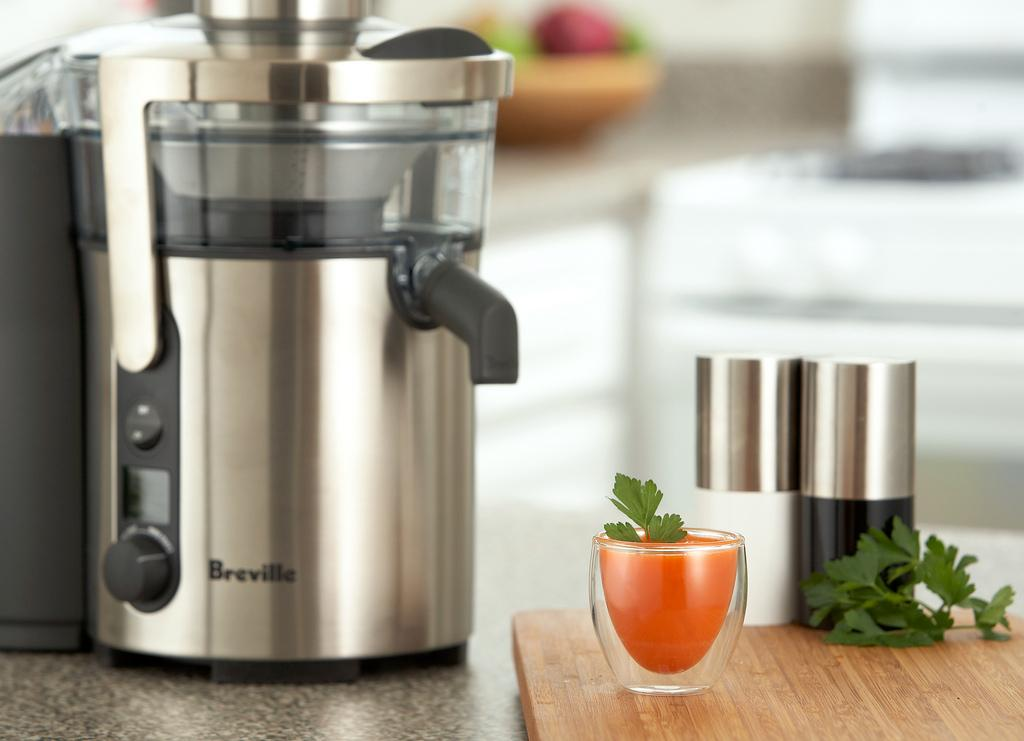<image>
Write a terse but informative summary of the picture. A Breville juicer sits on a counter top with a glass or carrot juice in front of it. 